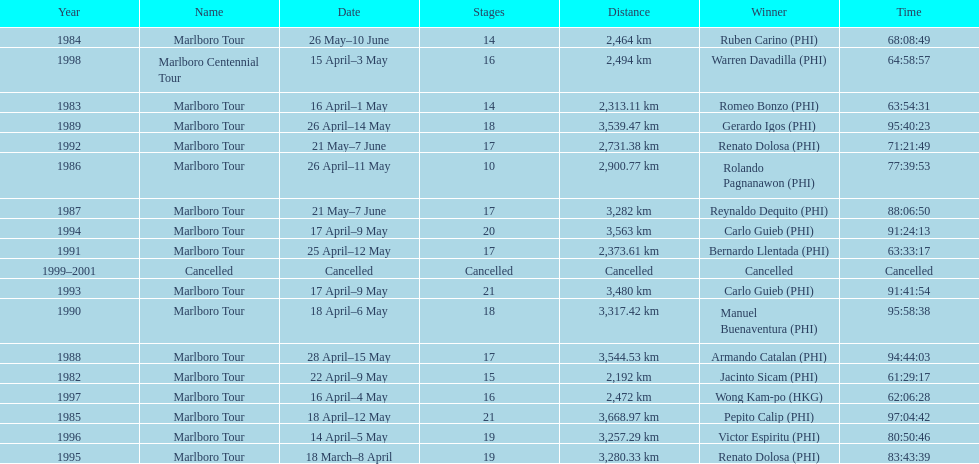What was the largest distance traveled for the marlboro tour? 3,668.97 km. 